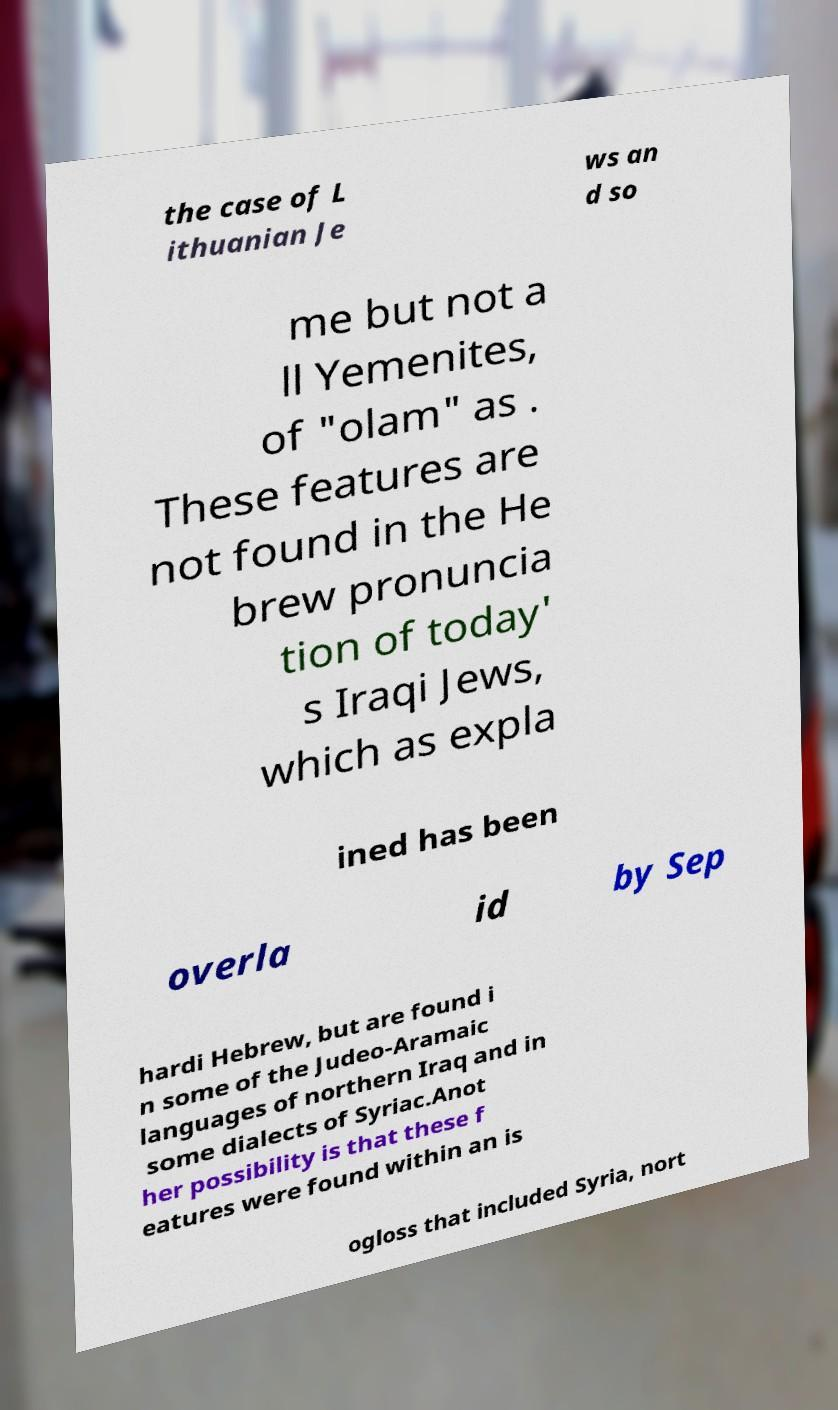Could you extract and type out the text from this image? the case of L ithuanian Je ws an d so me but not a ll Yemenites, of "olam" as . These features are not found in the He brew pronuncia tion of today' s Iraqi Jews, which as expla ined has been overla id by Sep hardi Hebrew, but are found i n some of the Judeo-Aramaic languages of northern Iraq and in some dialects of Syriac.Anot her possibility is that these f eatures were found within an is ogloss that included Syria, nort 